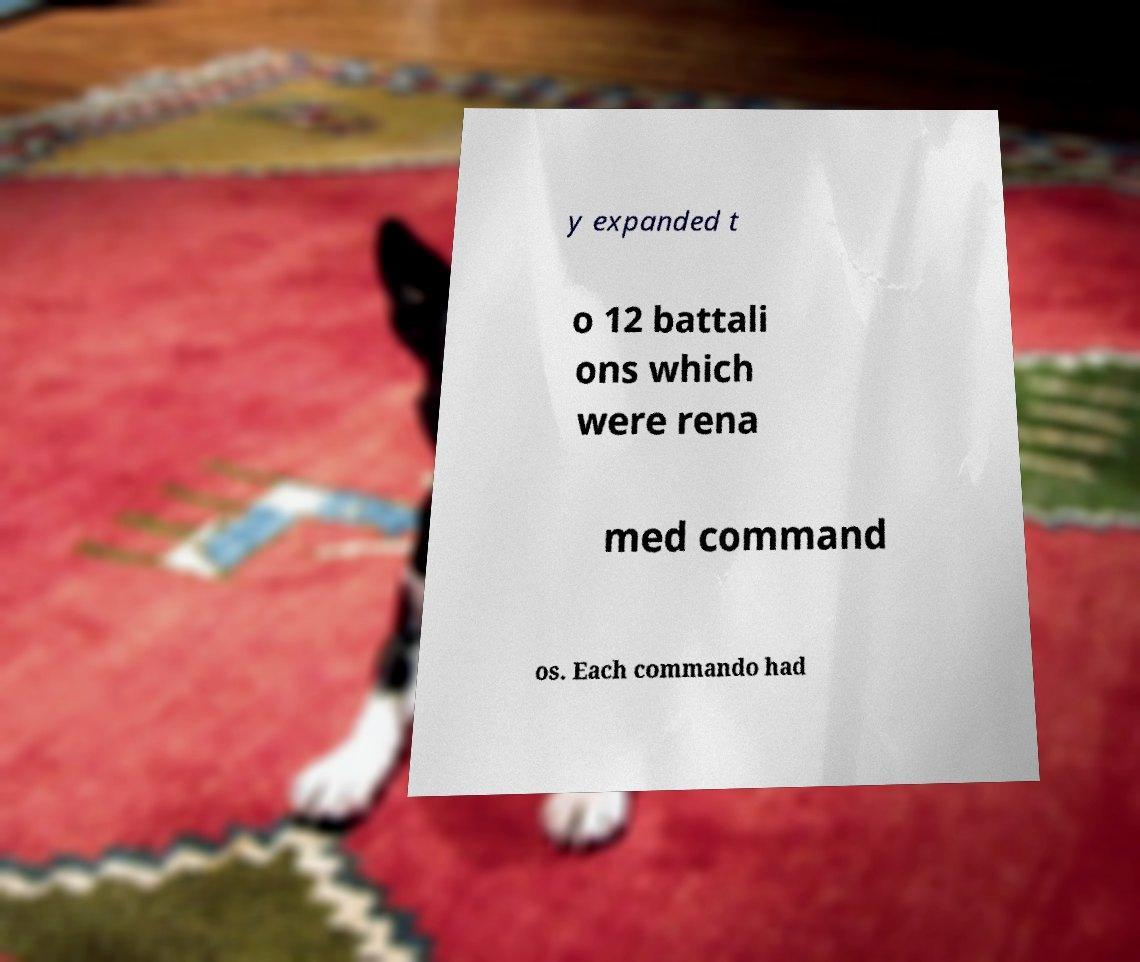What messages or text are displayed in this image? I need them in a readable, typed format. y expanded t o 12 battali ons which were rena med command os. Each commando had 